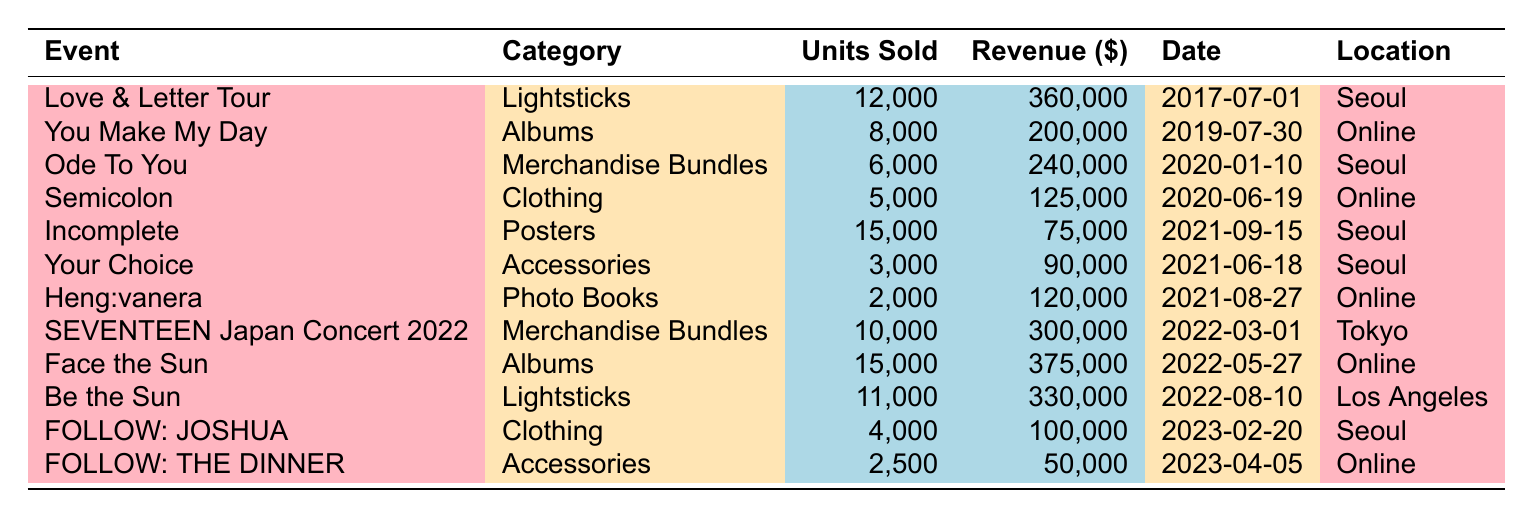What is the total revenue from the "Albums" category? The "Albums" category includes two events: "You Make My Day" with a revenue of $200,000 and "Face the Sun" with a revenue of $375,000. Adding these revenues gives a total of $200,000 + $375,000 = $575,000.
Answer: $575,000 Which event had the highest units sold? The event "Incomplete" had the highest units sold at 15,000. This can be directly observed from the units sold column in the table.
Answer: 15,000 How many lightsticks were sold in total? There are two events under the "Lightsticks" category: "Love & Letter Tour" with 12,000 units sold and "Be the Sun" with 11,000 units sold. Adding these together gives 12,000 + 11,000 = 23,000 lightsticks sold.
Answer: 23,000 What percentage of the total revenue comes from the "Merchandise Bundles" category? The "Merchandise Bundles" category has two events: "Ode To You" with $240,000 and "SEVENTEEN Japan Concert 2022" with $300,000. The total revenue from these events is $240,000 + $300,000 = $540,000. The total revenue across all events is $360,000 + $200,000 + $240,000 + $125,000 + $75,000 + $90,000 + $120,000 + $300,000 + $375,000 + $330,000 + $100,000 + $50,000 = $2,275,000. The percentage is then ($540,000 / $2,275,000) * 100 = 23.74%.
Answer: 23.74% Is the total number of units sold greater for online events compared to in-person events? The total units sold for online events are 8,000 (You Make My Day) + 6,000 (Ode To You) + 5,000 (Semicolon) + 2,000 (Heng:vanera) + 15,000 (Face the Sun) + 2,500 (FOLLOW: THE DINNER) = 38,500 units. The total for in-person (Seoul, Tokyo, Los Angeles) events is 12,000 + 6,000 + 5,000 + 15,000 + 11,000 + 4,000 = 53,000 units. 53,000 > 38,500, so the total units sold for in-person events is greater.
Answer: Yes What is the average revenue of the items sold in the "Clothing" category? The events in the "Clothing" category are "Semicolon" with $125,000 and "FOLLOW: JOSHUA" with $100,000. To find the average, add these revenues: $125,000 + $100,000 = $225,000. Then divide by the number of events in the category, which is 2. The average revenue is $225,000 / 2 = $112,500.
Answer: $112,500 Which location generated the most revenue? The location "Online" generated revenues from "You Make My Day" ($200,000), "Face the Sun" ($375,000), "Heng:vanera" ($120,000), and "FOLLOW: THE DINNER" ($50,000), totaling $200,000 + $375,000 + $120,000 + $50,000 = $745,000. The "Seoul" location generated $360,000 + $240,000 + $75,000 + $90,000 + $100,000 = $865,000, which is greater than Online, hence Seoul had the highest revenue.
Answer: Seoul 